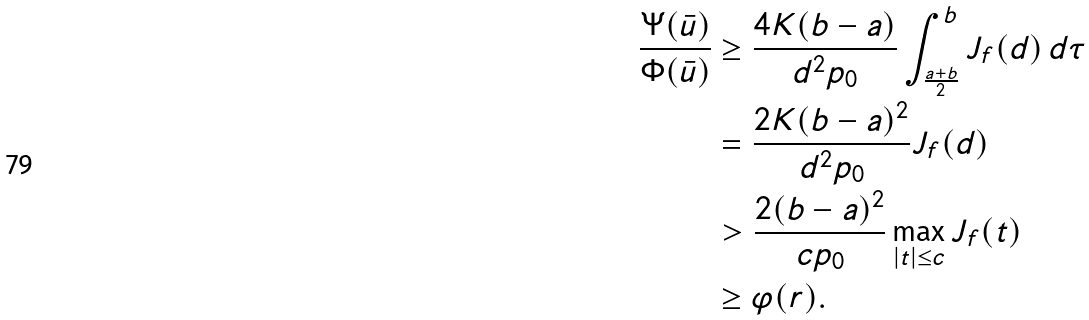Convert formula to latex. <formula><loc_0><loc_0><loc_500><loc_500>\frac { \Psi ( \bar { u } ) } { \Phi ( \bar { u } ) } & \geq \frac { 4 K ( b - a ) } { d ^ { 2 } p _ { 0 } } \int _ { \frac { a + b } { 2 } } ^ { b } J _ { f } ( d ) \, d \tau \\ & = \frac { 2 K ( b - a ) ^ { 2 } } { d ^ { 2 } p _ { 0 } } J _ { f } ( d ) \\ & > \frac { 2 ( b - a ) ^ { 2 } } { c p _ { 0 } } \max _ { | t | \leq c } J _ { f } ( t ) \\ & \geq \varphi ( r ) .</formula> 